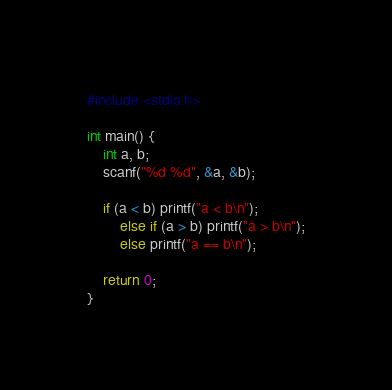Convert code to text. <code><loc_0><loc_0><loc_500><loc_500><_C_>#include <stdio.h>

int main() {
	int a, b;
	scanf("%d %d", &a, &b);

	if (a < b) printf("a < b\n");
        else if (a > b) printf("a > b\n");
        else printf("a == b\n");

	return 0;
}</code> 